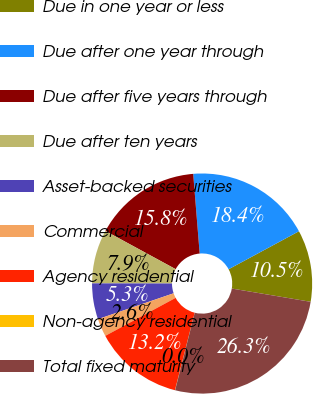Convert chart. <chart><loc_0><loc_0><loc_500><loc_500><pie_chart><fcel>Due in one year or less<fcel>Due after one year through<fcel>Due after five years through<fcel>Due after ten years<fcel>Asset-backed securities<fcel>Commercial<fcel>Agency residential<fcel>Non-agency residential<fcel>Total fixed maturity<nl><fcel>10.53%<fcel>18.41%<fcel>15.78%<fcel>7.9%<fcel>5.27%<fcel>2.64%<fcel>13.15%<fcel>0.02%<fcel>26.29%<nl></chart> 